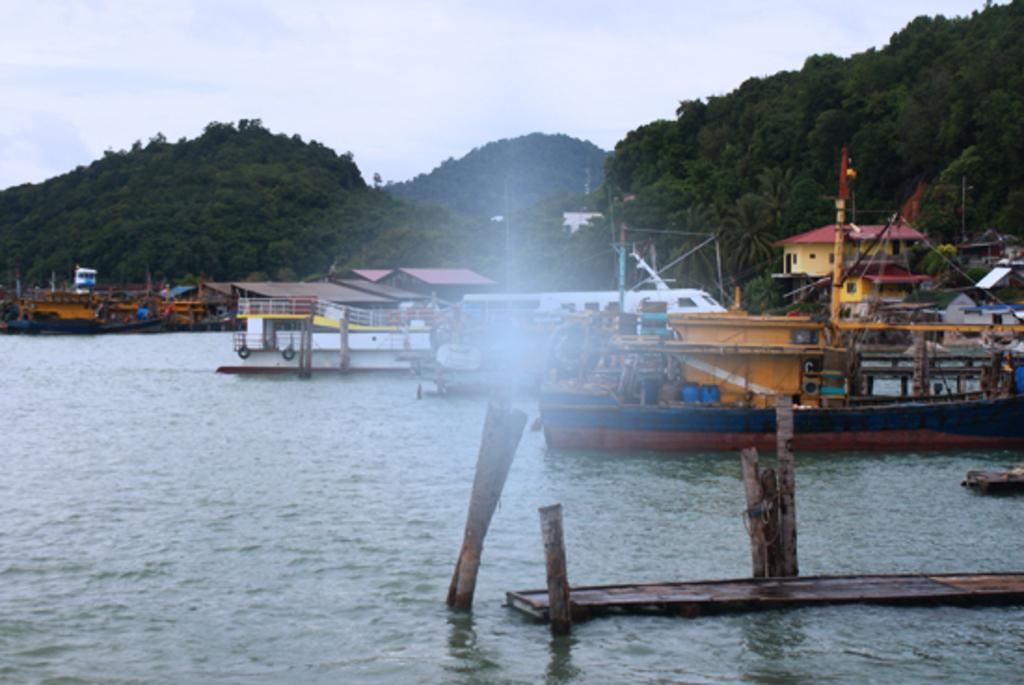What is the main feature in the center of the image? There is a lake in the center of the image. What is on the lake in the image? There are ships on the lake. What can be seen in the distance in the image? There are hills visible in the background of the image. What else is visible in the background of the image? The sky is visible in the background of the image. Are there any babies playing a game with a fork in the image? There are no babies or forks present in the image. 